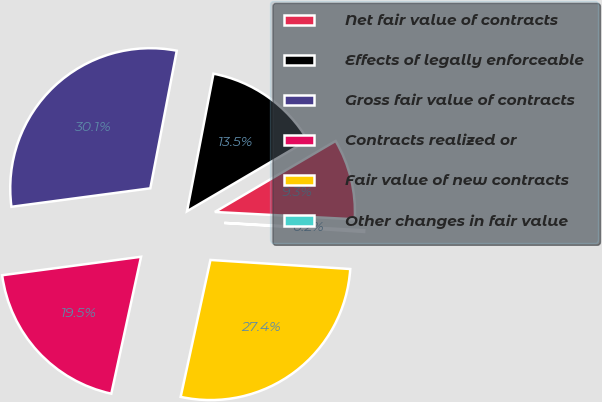<chart> <loc_0><loc_0><loc_500><loc_500><pie_chart><fcel>Net fair value of contracts<fcel>Effects of legally enforceable<fcel>Gross fair value of contracts<fcel>Contracts realized or<fcel>Fair value of new contracts<fcel>Other changes in fair value<nl><fcel>9.29%<fcel>13.52%<fcel>30.13%<fcel>19.49%<fcel>27.38%<fcel>0.2%<nl></chart> 